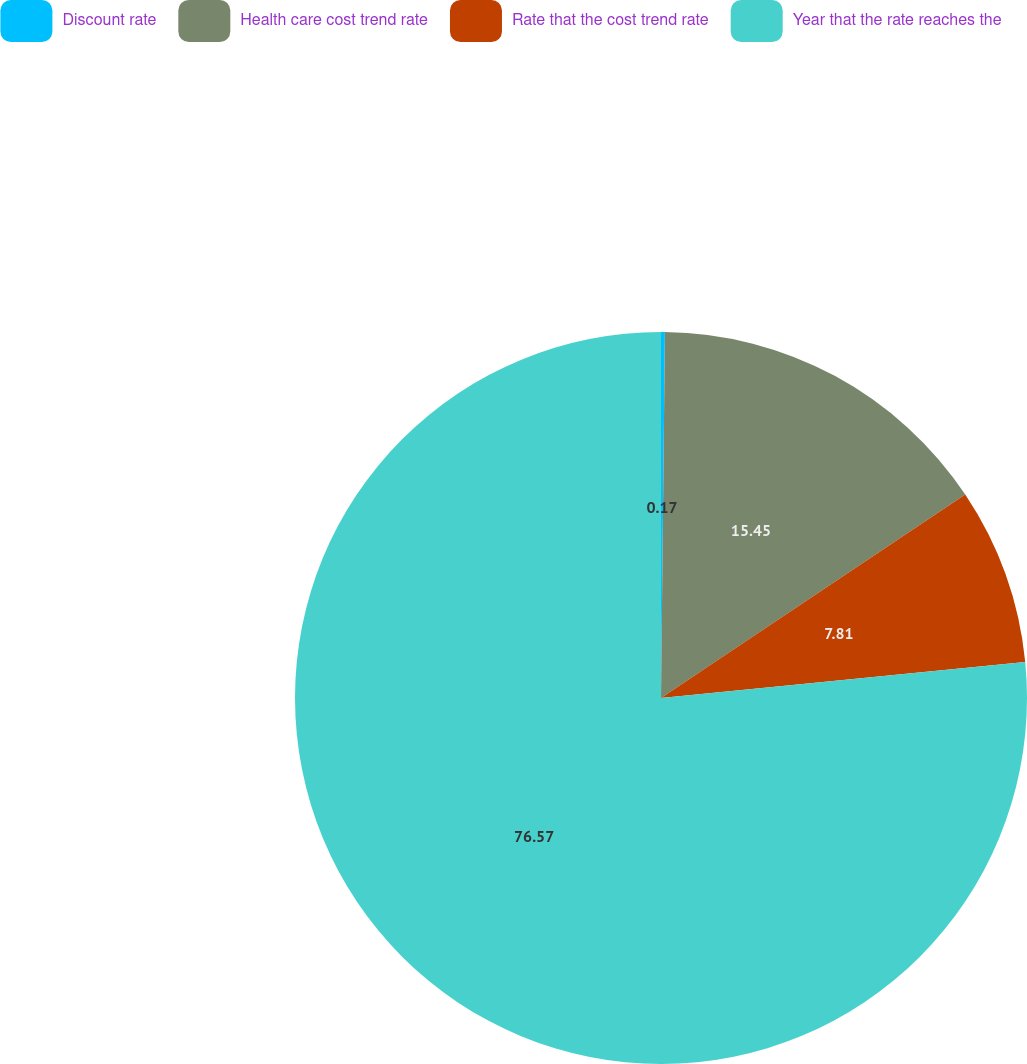<chart> <loc_0><loc_0><loc_500><loc_500><pie_chart><fcel>Discount rate<fcel>Health care cost trend rate<fcel>Rate that the cost trend rate<fcel>Year that the rate reaches the<nl><fcel>0.17%<fcel>15.45%<fcel>7.81%<fcel>76.57%<nl></chart> 